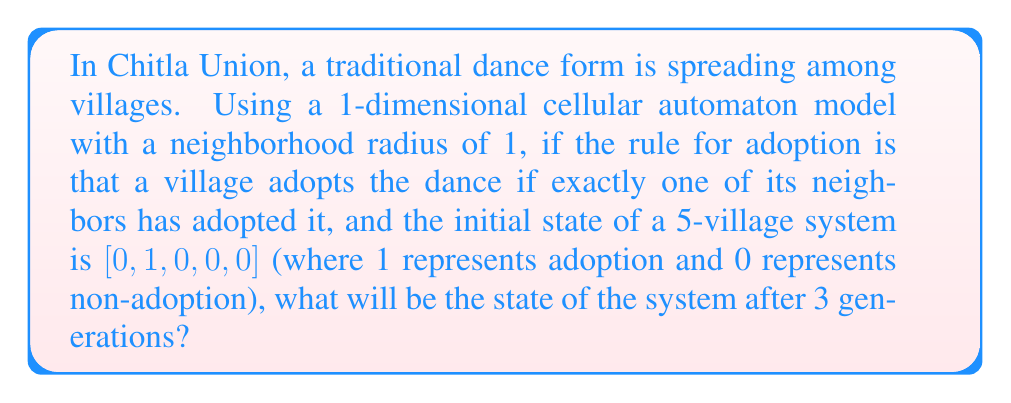Teach me how to tackle this problem. Let's approach this step-by-step:

1) First, let's define our cellular automaton:
   - It's 1-dimensional
   - Neighborhood radius is 1 (each cell considers itself and its immediate neighbors)
   - Rule: A cell becomes 1 if exactly one of its neighbors is 1, otherwise it's 0
   - Initial state: [0,1,0,0,0]

2) Let's evolve the system generation by generation:

   Generation 0: [0,1,0,0,0]

3) For Generation 1:
   - Cell 1: Right neighbor is 1, becomes 1
   - Cell 2: Both neighbors are 0, becomes 0
   - Cell 3: Left neighbor is 1, becomes 1
   - Cell 4: Both neighbors are 0, stays 0
   - Cell 5: Left neighbor is 0, stays 0
   Generation 1: [1,0,1,0,0]

4) For Generation 2:
   - Cell 1: Right neighbor is 0, becomes 0
   - Cell 2: Both neighbors are 1, stays 0
   - Cell 3: Both neighbors are 0, becomes 0
   - Cell 4: Left neighbor is 1, becomes 1
   - Cell 5: Left neighbor is 0, stays 0
   Generation 2: [0,0,0,1,0]

5) For Generation 3:
   - Cell 1: Both neighbors are 0, stays 0
   - Cell 2: Right neighbor is 0, stays 0
   - Cell 3: Right neighbor is 1, becomes 1
   - Cell 4: Both neighbors are 0, becomes 0
   - Cell 5: Left neighbor is 1, becomes 1
   Generation 3: [0,0,1,0,1]

Therefore, after 3 generations, the state of the system will be [0,0,1,0,1].
Answer: [0,0,1,0,1] 